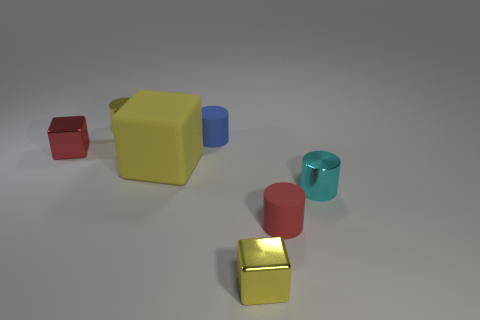Subtract 1 cylinders. How many cylinders are left? 3 Add 3 large green shiny things. How many objects exist? 10 Subtract all blocks. How many objects are left? 4 Subtract all large red matte cylinders. Subtract all cyan shiny cylinders. How many objects are left? 6 Add 2 tiny blocks. How many tiny blocks are left? 4 Add 7 large cyan things. How many large cyan things exist? 7 Subtract 0 brown blocks. How many objects are left? 7 